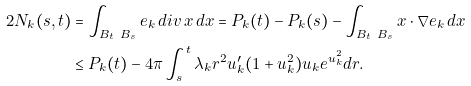Convert formula to latex. <formula><loc_0><loc_0><loc_500><loc_500>2 N _ { k } ( s , t ) & = \int _ { B _ { t } \ B _ { s } } e _ { k } \, d i v \, x \, d x = P _ { k } ( t ) - P _ { k } ( s ) - \int _ { B _ { t } \ B _ { s } } x \cdot \nabla e _ { k } \, d x \\ & \leq P _ { k } ( t ) - 4 \pi \int _ { s } ^ { t } \lambda _ { k } r ^ { 2 } u _ { k } ^ { \prime } ( 1 + u _ { k } ^ { 2 } ) u _ { k } e ^ { u _ { k } ^ { 2 } } d r .</formula> 